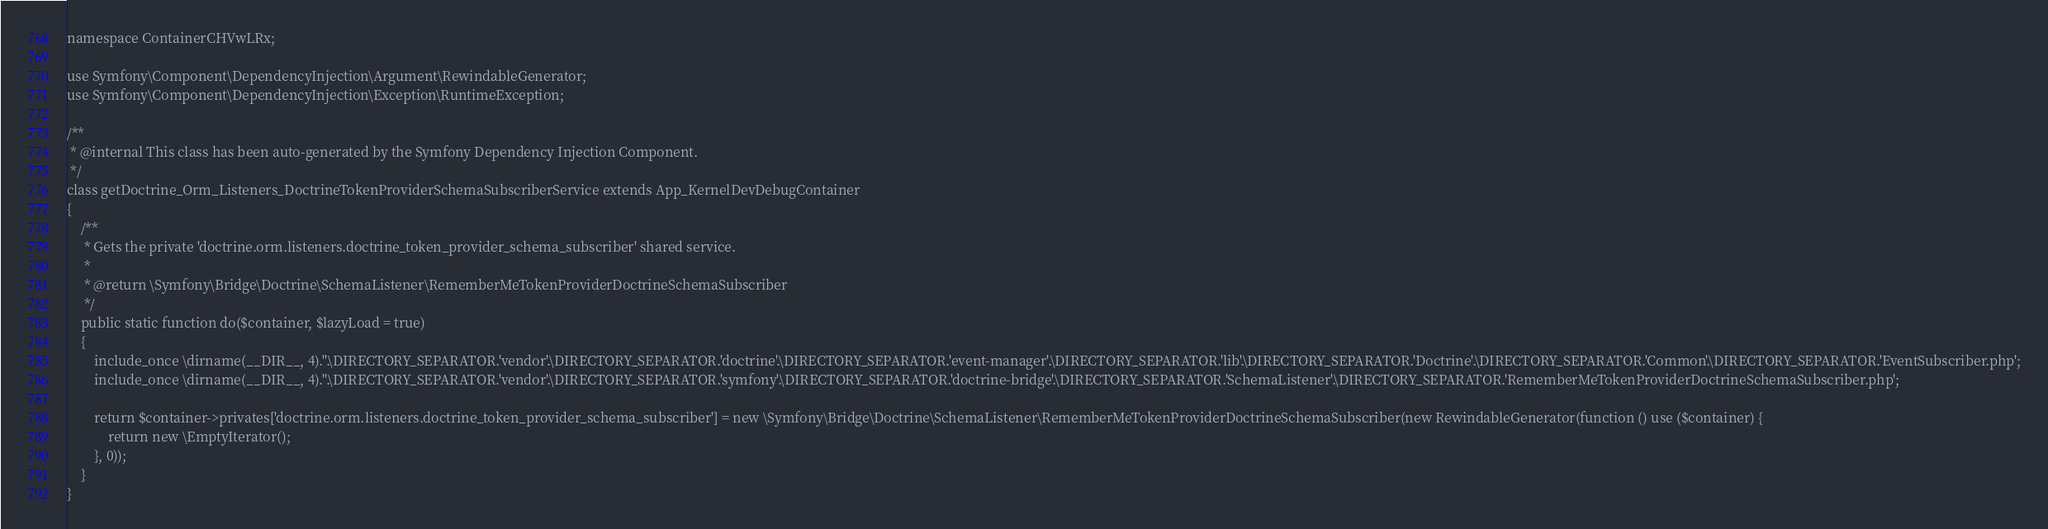<code> <loc_0><loc_0><loc_500><loc_500><_PHP_>namespace ContainerCHVwLRx;

use Symfony\Component\DependencyInjection\Argument\RewindableGenerator;
use Symfony\Component\DependencyInjection\Exception\RuntimeException;

/**
 * @internal This class has been auto-generated by the Symfony Dependency Injection Component.
 */
class getDoctrine_Orm_Listeners_DoctrineTokenProviderSchemaSubscriberService extends App_KernelDevDebugContainer
{
    /**
     * Gets the private 'doctrine.orm.listeners.doctrine_token_provider_schema_subscriber' shared service.
     *
     * @return \Symfony\Bridge\Doctrine\SchemaListener\RememberMeTokenProviderDoctrineSchemaSubscriber
     */
    public static function do($container, $lazyLoad = true)
    {
        include_once \dirname(__DIR__, 4).''.\DIRECTORY_SEPARATOR.'vendor'.\DIRECTORY_SEPARATOR.'doctrine'.\DIRECTORY_SEPARATOR.'event-manager'.\DIRECTORY_SEPARATOR.'lib'.\DIRECTORY_SEPARATOR.'Doctrine'.\DIRECTORY_SEPARATOR.'Common'.\DIRECTORY_SEPARATOR.'EventSubscriber.php';
        include_once \dirname(__DIR__, 4).''.\DIRECTORY_SEPARATOR.'vendor'.\DIRECTORY_SEPARATOR.'symfony'.\DIRECTORY_SEPARATOR.'doctrine-bridge'.\DIRECTORY_SEPARATOR.'SchemaListener'.\DIRECTORY_SEPARATOR.'RememberMeTokenProviderDoctrineSchemaSubscriber.php';

        return $container->privates['doctrine.orm.listeners.doctrine_token_provider_schema_subscriber'] = new \Symfony\Bridge\Doctrine\SchemaListener\RememberMeTokenProviderDoctrineSchemaSubscriber(new RewindableGenerator(function () use ($container) {
            return new \EmptyIterator();
        }, 0));
    }
}
</code> 